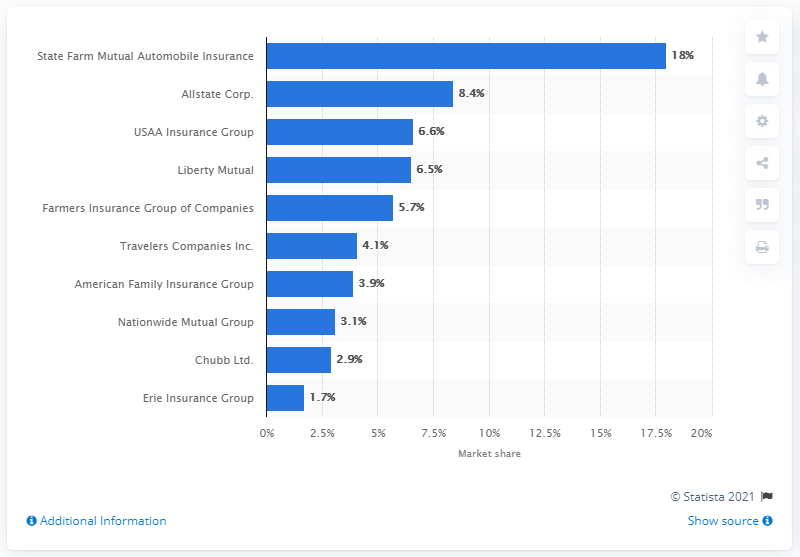Give some essential details in this illustration. According to data from 2019, Liberty Mutual held a market share of 6.5 percent among insurance companies. 